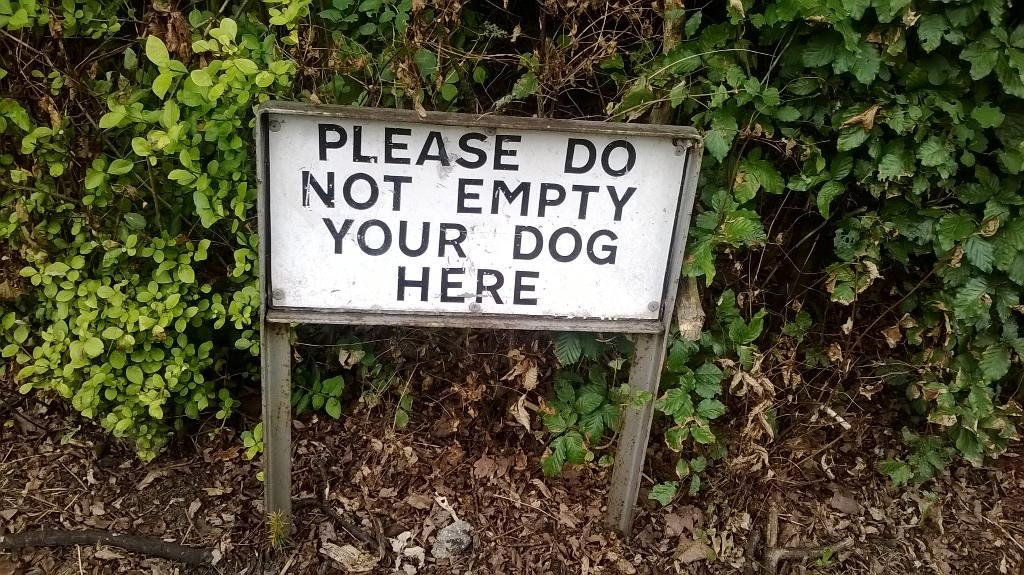What is located at the front of the image? There is an information board in the front of the image. What can be seen in the background of the image? There are plants in the background of the image. What advice is given on the information board in the image? There is no advice present on the information board in the image; it is simply an information board with no text or content visible. 